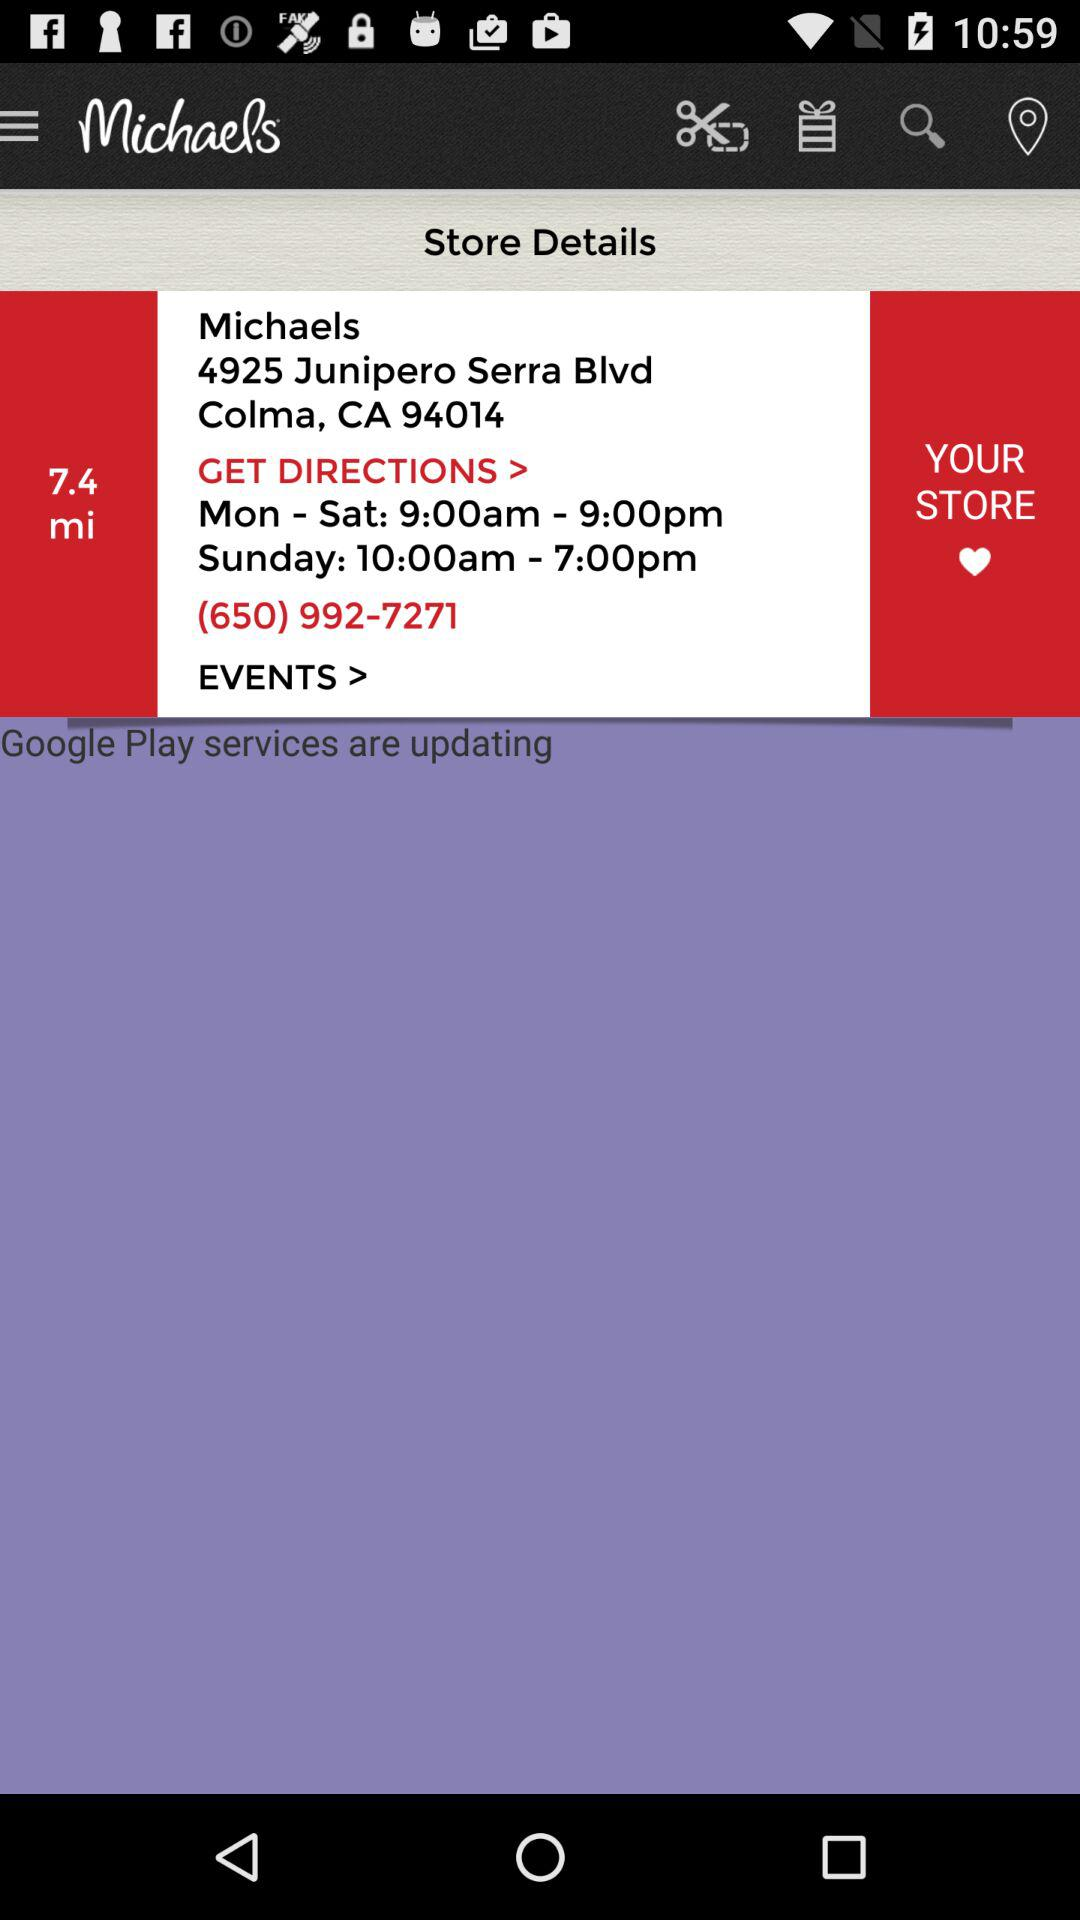What is the distance to the store?
Answer the question using a single word or phrase. 7.4 mi 